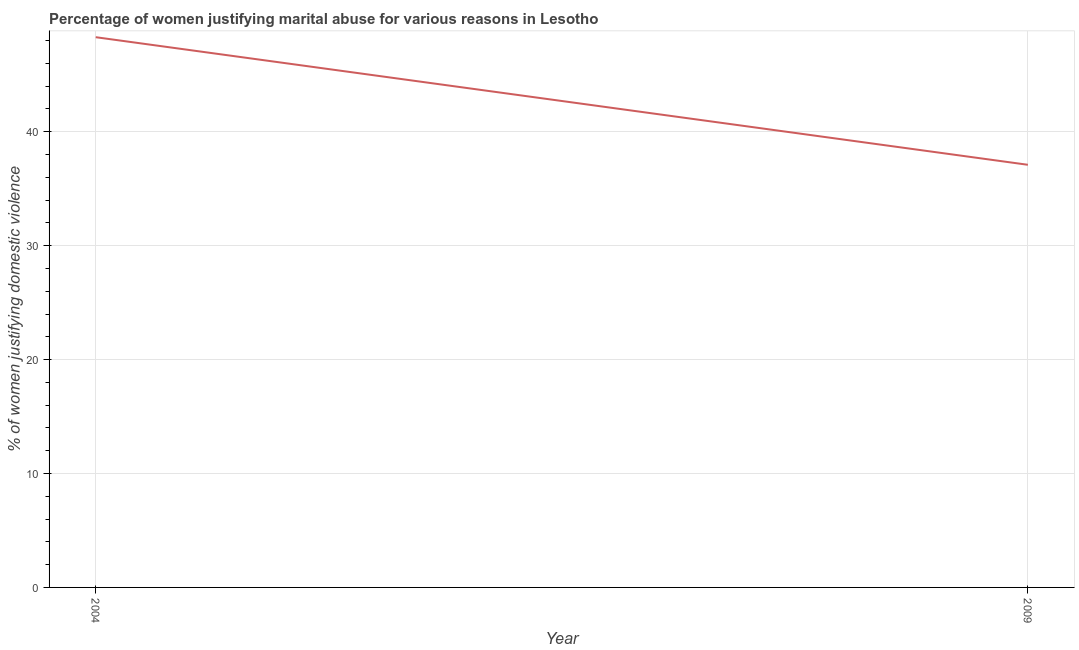What is the percentage of women justifying marital abuse in 2004?
Your answer should be compact. 48.3. Across all years, what is the maximum percentage of women justifying marital abuse?
Keep it short and to the point. 48.3. Across all years, what is the minimum percentage of women justifying marital abuse?
Your answer should be compact. 37.1. In which year was the percentage of women justifying marital abuse maximum?
Offer a terse response. 2004. In which year was the percentage of women justifying marital abuse minimum?
Your answer should be very brief. 2009. What is the sum of the percentage of women justifying marital abuse?
Provide a succinct answer. 85.4. What is the difference between the percentage of women justifying marital abuse in 2004 and 2009?
Your response must be concise. 11.2. What is the average percentage of women justifying marital abuse per year?
Your answer should be very brief. 42.7. What is the median percentage of women justifying marital abuse?
Your answer should be compact. 42.7. Do a majority of the years between 2009 and 2004 (inclusive) have percentage of women justifying marital abuse greater than 2 %?
Provide a succinct answer. No. What is the ratio of the percentage of women justifying marital abuse in 2004 to that in 2009?
Your answer should be very brief. 1.3. Is the percentage of women justifying marital abuse in 2004 less than that in 2009?
Provide a short and direct response. No. In how many years, is the percentage of women justifying marital abuse greater than the average percentage of women justifying marital abuse taken over all years?
Make the answer very short. 1. Does the percentage of women justifying marital abuse monotonically increase over the years?
Offer a terse response. No. What is the difference between two consecutive major ticks on the Y-axis?
Offer a terse response. 10. Does the graph contain any zero values?
Offer a very short reply. No. What is the title of the graph?
Keep it short and to the point. Percentage of women justifying marital abuse for various reasons in Lesotho. What is the label or title of the Y-axis?
Your answer should be very brief. % of women justifying domestic violence. What is the % of women justifying domestic violence of 2004?
Provide a succinct answer. 48.3. What is the % of women justifying domestic violence of 2009?
Your answer should be compact. 37.1. What is the ratio of the % of women justifying domestic violence in 2004 to that in 2009?
Ensure brevity in your answer.  1.3. 